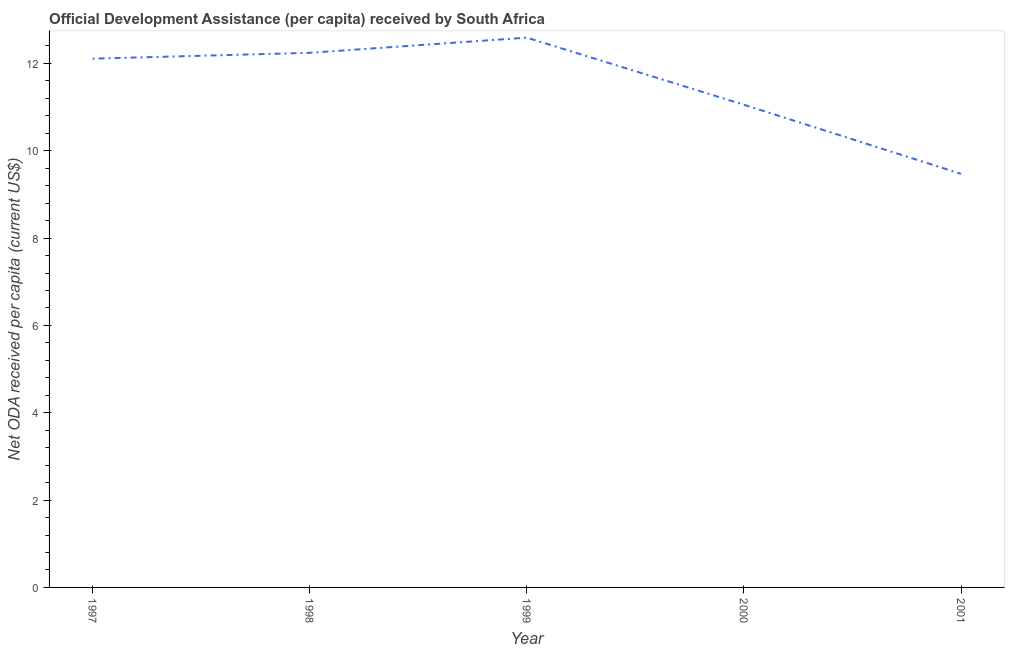What is the net oda received per capita in 1999?
Provide a succinct answer. 12.59. Across all years, what is the maximum net oda received per capita?
Ensure brevity in your answer.  12.59. Across all years, what is the minimum net oda received per capita?
Your response must be concise. 9.47. What is the sum of the net oda received per capita?
Provide a succinct answer. 57.47. What is the difference between the net oda received per capita in 1997 and 1998?
Provide a short and direct response. -0.13. What is the average net oda received per capita per year?
Your answer should be very brief. 11.49. What is the median net oda received per capita?
Your answer should be compact. 12.11. In how many years, is the net oda received per capita greater than 1.6 US$?
Offer a very short reply. 5. What is the ratio of the net oda received per capita in 1999 to that in 2000?
Provide a succinct answer. 1.14. What is the difference between the highest and the second highest net oda received per capita?
Offer a terse response. 0.35. Is the sum of the net oda received per capita in 1998 and 1999 greater than the maximum net oda received per capita across all years?
Your answer should be very brief. Yes. What is the difference between the highest and the lowest net oda received per capita?
Give a very brief answer. 3.12. How many lines are there?
Provide a succinct answer. 1. How many years are there in the graph?
Your answer should be compact. 5. Are the values on the major ticks of Y-axis written in scientific E-notation?
Your answer should be compact. No. What is the title of the graph?
Provide a short and direct response. Official Development Assistance (per capita) received by South Africa. What is the label or title of the Y-axis?
Offer a very short reply. Net ODA received per capita (current US$). What is the Net ODA received per capita (current US$) in 1997?
Ensure brevity in your answer.  12.11. What is the Net ODA received per capita (current US$) of 1998?
Ensure brevity in your answer.  12.24. What is the Net ODA received per capita (current US$) of 1999?
Your answer should be compact. 12.59. What is the Net ODA received per capita (current US$) in 2000?
Ensure brevity in your answer.  11.05. What is the Net ODA received per capita (current US$) of 2001?
Offer a terse response. 9.47. What is the difference between the Net ODA received per capita (current US$) in 1997 and 1998?
Make the answer very short. -0.13. What is the difference between the Net ODA received per capita (current US$) in 1997 and 1999?
Provide a succinct answer. -0.48. What is the difference between the Net ODA received per capita (current US$) in 1997 and 2000?
Keep it short and to the point. 1.06. What is the difference between the Net ODA received per capita (current US$) in 1997 and 2001?
Provide a short and direct response. 2.64. What is the difference between the Net ODA received per capita (current US$) in 1998 and 1999?
Your answer should be compact. -0.35. What is the difference between the Net ODA received per capita (current US$) in 1998 and 2000?
Provide a succinct answer. 1.19. What is the difference between the Net ODA received per capita (current US$) in 1998 and 2001?
Your answer should be very brief. 2.77. What is the difference between the Net ODA received per capita (current US$) in 1999 and 2000?
Offer a very short reply. 1.54. What is the difference between the Net ODA received per capita (current US$) in 1999 and 2001?
Provide a short and direct response. 3.12. What is the difference between the Net ODA received per capita (current US$) in 2000 and 2001?
Keep it short and to the point. 1.58. What is the ratio of the Net ODA received per capita (current US$) in 1997 to that in 1998?
Give a very brief answer. 0.99. What is the ratio of the Net ODA received per capita (current US$) in 1997 to that in 2000?
Your answer should be very brief. 1.09. What is the ratio of the Net ODA received per capita (current US$) in 1997 to that in 2001?
Provide a succinct answer. 1.28. What is the ratio of the Net ODA received per capita (current US$) in 1998 to that in 1999?
Keep it short and to the point. 0.97. What is the ratio of the Net ODA received per capita (current US$) in 1998 to that in 2000?
Keep it short and to the point. 1.11. What is the ratio of the Net ODA received per capita (current US$) in 1998 to that in 2001?
Your answer should be very brief. 1.29. What is the ratio of the Net ODA received per capita (current US$) in 1999 to that in 2000?
Your answer should be compact. 1.14. What is the ratio of the Net ODA received per capita (current US$) in 1999 to that in 2001?
Ensure brevity in your answer.  1.33. What is the ratio of the Net ODA received per capita (current US$) in 2000 to that in 2001?
Keep it short and to the point. 1.17. 